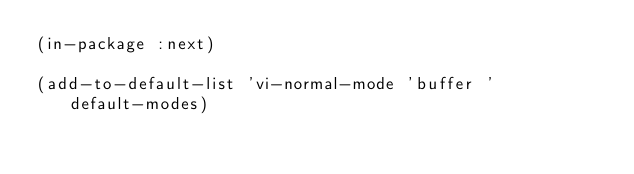<code> <loc_0><loc_0><loc_500><loc_500><_Lisp_>(in-package :next)

(add-to-default-list 'vi-normal-mode 'buffer 'default-modes)
</code> 